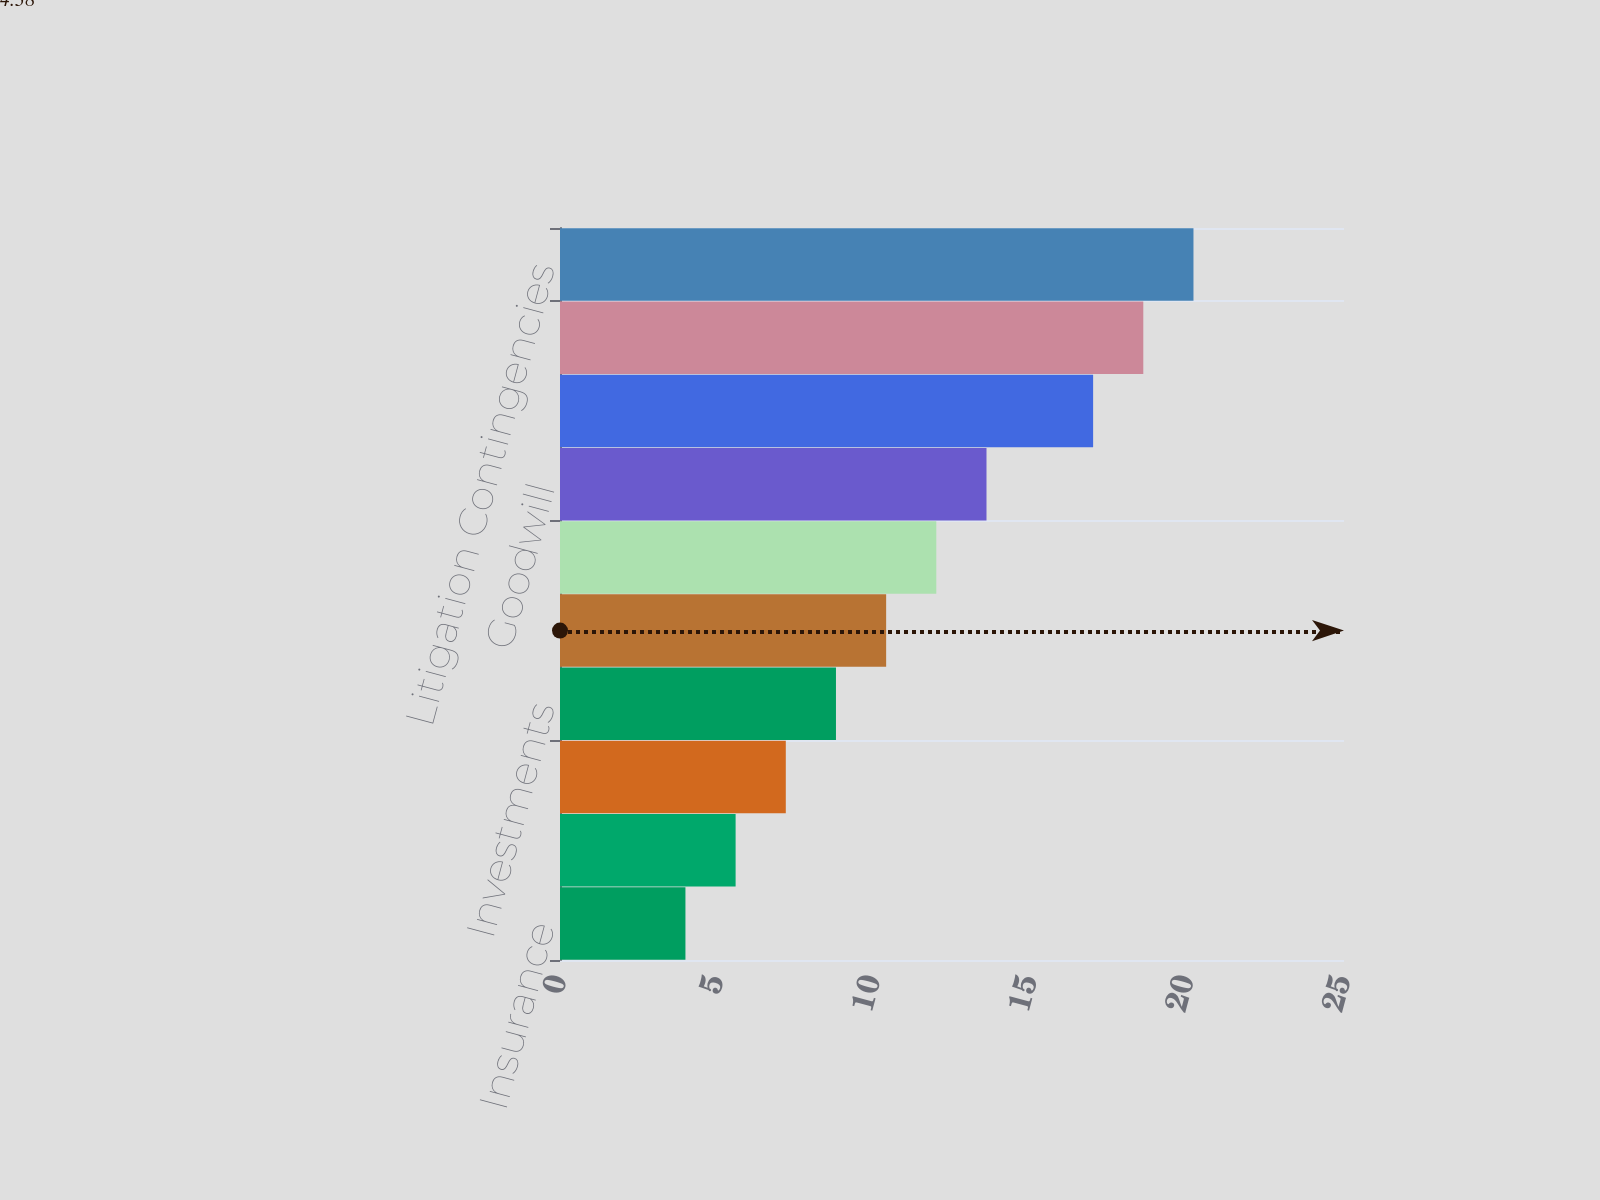<chart> <loc_0><loc_0><loc_500><loc_500><bar_chart><fcel>Insurance<fcel>Deferred Policy Acquisition<fcel>Reinsurance<fcel>Investments<fcel>Derivatives<fcel>Fair Value<fcel>Goodwill<fcel>Employee Benefit Plans<fcel>Income Tax<fcel>Litigation Contingencies<nl><fcel>4<fcel>5.6<fcel>7.2<fcel>8.8<fcel>10.4<fcel>12<fcel>13.6<fcel>17<fcel>18.6<fcel>20.2<nl></chart> 